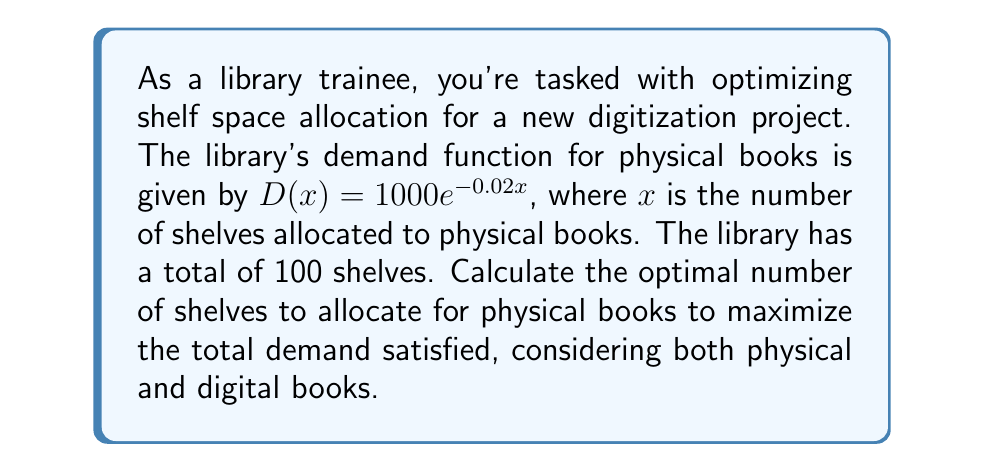Provide a solution to this math problem. To solve this problem, we'll use integration techniques:

1) The total demand satisfied is the sum of physical and digital book demand.

2) For physical books, the demand is given by the integral of $D(x)$ from 0 to $x$:

   $$\int_0^x 1000e^{-0.02t} dt$$

3) Solve this integral:
   
   $$[-50000e^{-0.02t}]_0^x = -50000e^{-0.02x} + 50000$$

4) For digital books, we assume they can satisfy all remaining demand. The number of shelves for digital books is $(100-x)$, and the demand is:

   $$1000 - 1000e^{-0.02x}$$

5) Total demand satisfied $T(x)$ is the sum of these:

   $$T(x) = (-50000e^{-0.02x} + 50000) + (1000 - 1000e^{-0.02x})$$
   $$T(x) = 51000 - 51000e^{-0.02x}$$

6) To find the maximum, differentiate and set to zero:

   $$T'(x) = 1020e^{-0.02x}$$
   $$1020e^{-0.02x} = 0$$

7) This equation is never exactly zero, but approaches it as $x$ approaches infinity. In practice, we need to consider the constraints.

8) Given the total 100 shelves, evaluate $T(x)$ at the endpoints:

   At $x=0$: $T(0) = 0$
   At $x=100$: $T(100) = 51000 - 51000e^{-2} \approx 32453.34$

9) Therefore, the optimal allocation is to use all 100 shelves for physical books.
Answer: 100 shelves 